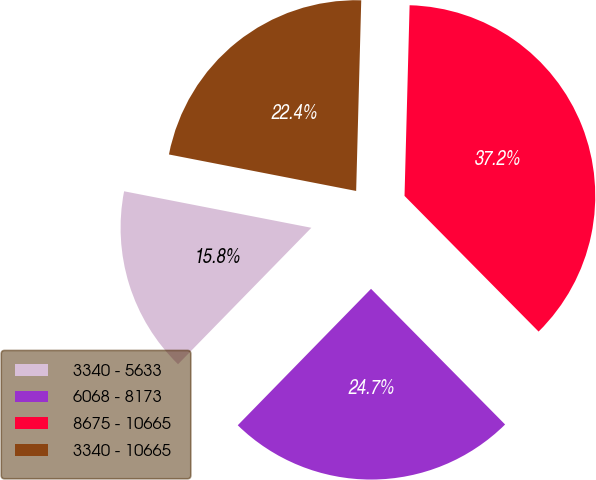Convert chart. <chart><loc_0><loc_0><loc_500><loc_500><pie_chart><fcel>3340 - 5633<fcel>6068 - 8173<fcel>8675 - 10665<fcel>3340 - 10665<nl><fcel>15.75%<fcel>24.72%<fcel>37.17%<fcel>22.36%<nl></chart> 